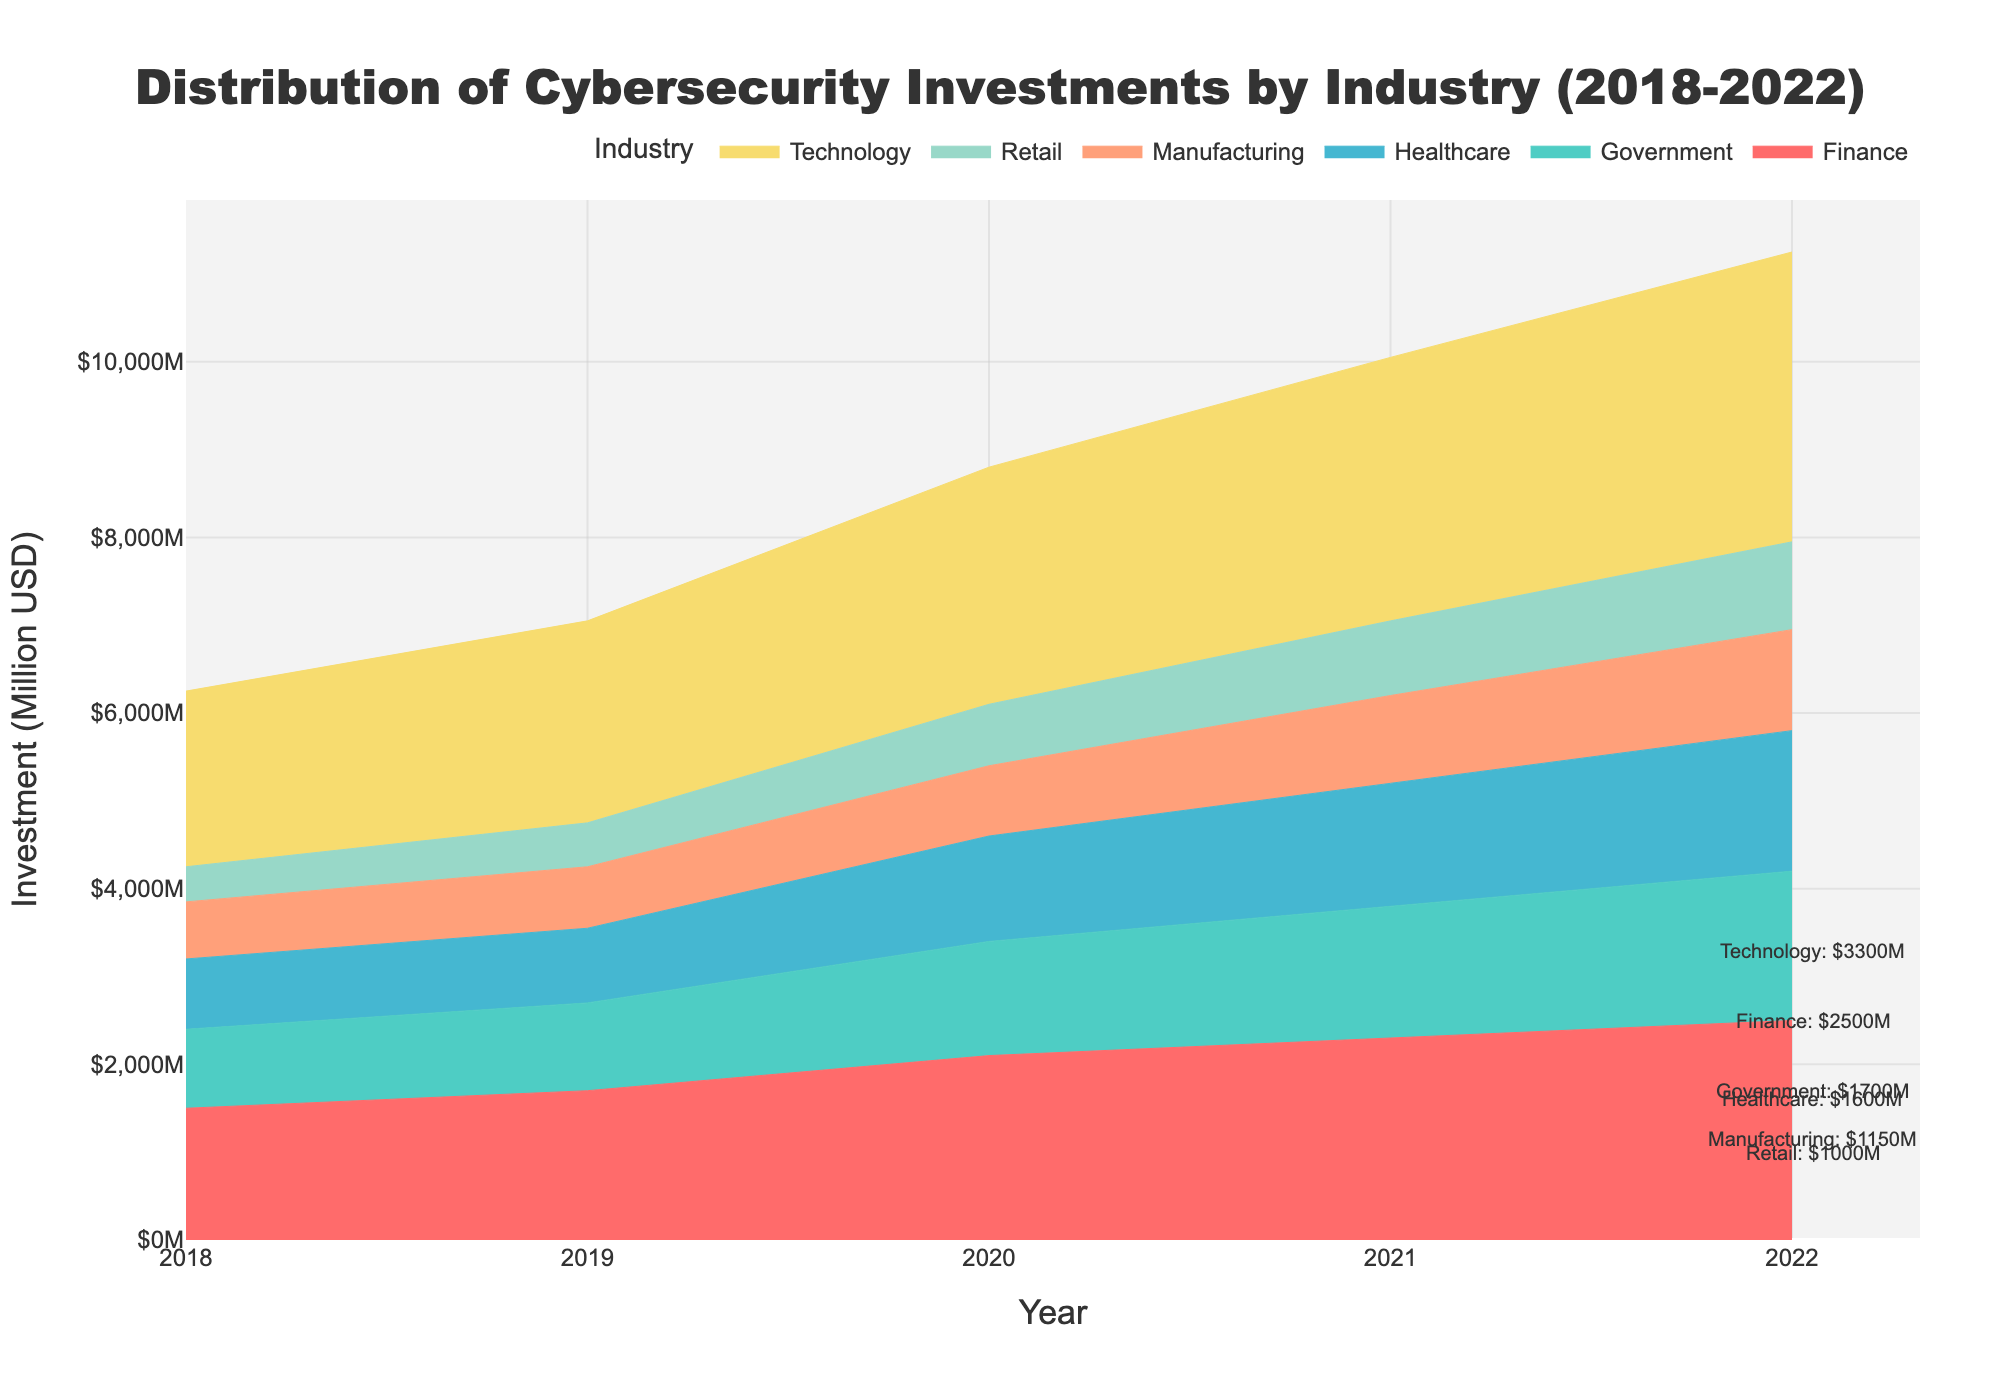What is the title of the chart? The title of the chart is written at the top center of the figure. It reads "Distribution of Cybersecurity Investments by Industry (2018-2022)".
Answer: Distribution of Cybersecurity Investments by Industry (2018-2022) Which industry had the highest cybersecurity investment in 2022? To find the answer, look at the end of the chart (Year 2022) and see which colored stack reaches the highest point. The "Technology" industry is at the top.
Answer: Technology What was the overall trend in cybersecurity investments for the Healthcare industry from 2018 to 2022? Look at the area representing Healthcare over the years 2018 to 2022. The area size increases consistently, indicating a rising trend.
Answer: Increasing How much did the Government industry invest in cybersecurity in 2019? Locate the year 2019 on the x-axis and trace the height of the Government industry color. According to the annotation, it is $1000M.
Answer: $1000M Between 2021 and 2022, which industry saw the greatest increase in cybersecurity investments? Compare the height of each industry's color between 2021 and 2022. The difference looks the largest for the Technology industry.
Answer: Technology What is the difference in cybersecurity investments between the Finance and Retail industries in 2022? Look at the heights of Finance and Retail in 2022. Finance is $2500M, and Retail is $1000M. Subtract Retail's value from Finance's.
Answer: $1500M Compare the cybersecurity investments in 2020 for Finance and Healthcare. Which one had a higher investment, and by how much? For 2020, find the investment heights for Finance ($2100M) and Healthcare ($1200M). Subtract Healthcare’s from Finance’s to get the difference.
Answer: Finance by $900M As per the chart, did the Manufacturing industry’s cybersecurity investments ever decrease between 2018 and 2022? Observe the colored area for Manufacturing from 2018 to 2022. It consistently increases, so no decrease is noted.
Answer: No What was the average cybersecurity investment for the Retail industry from 2018 to 2022? Add the Retail investments from 2018 to 2022: (400 + 500 + 700 + 850 + 1000). Divide the total by 5 (number of years).
Answer: $690M Which year saw the lowest overall cybersecurity investment among all industries? Observe the total height of all stacked areas for each year. The year with the smallest total height is 2018.
Answer: 2018 